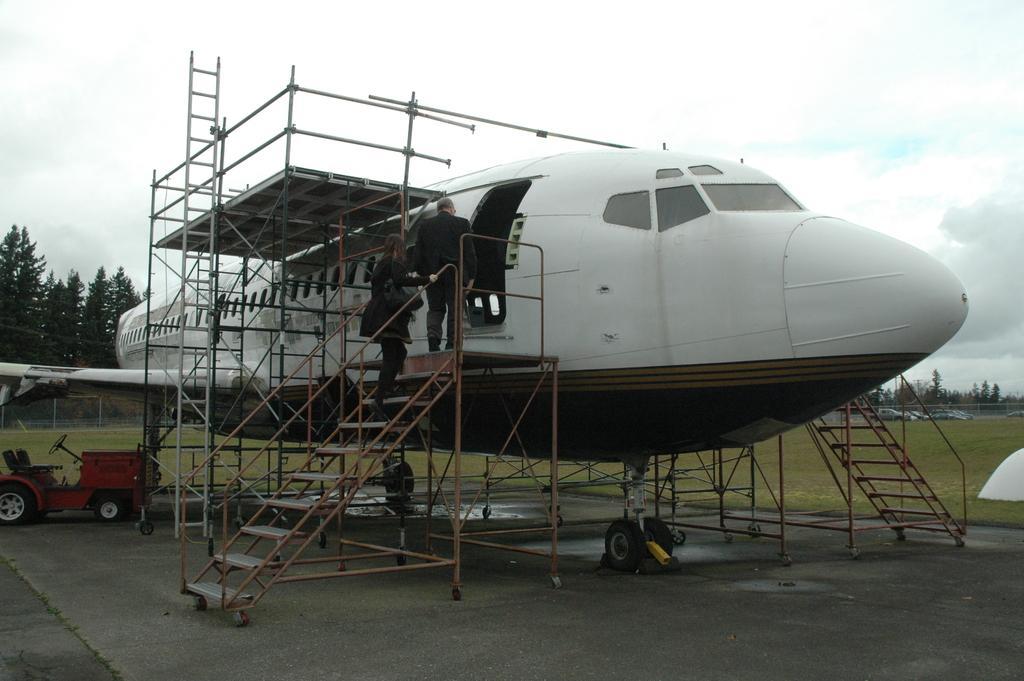Describe this image in one or two sentences. In this image I see an aeroplane which is of white in color and I see a woman and a man over here and I see the stairs over here and I see a vehicle over here and I see the road and I see many rods and I can also see another stairs over here. In the background I see the grass, trees, fencing and the sky. 